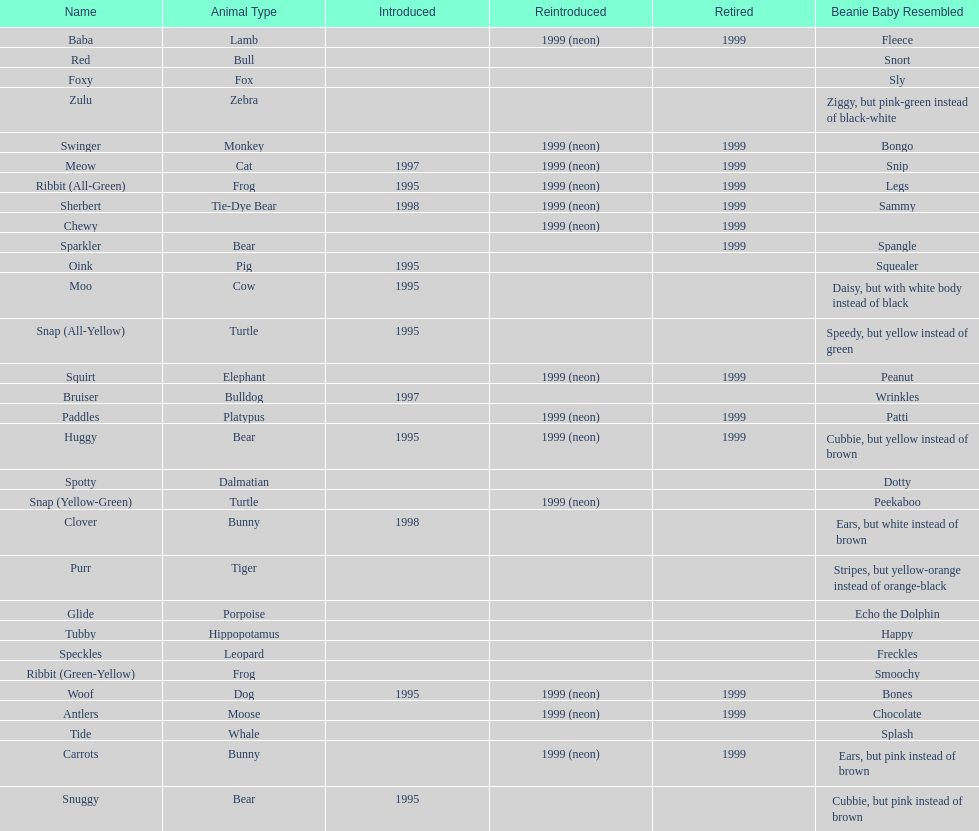What is the name of the pillow pal listed after clover? Foxy. 